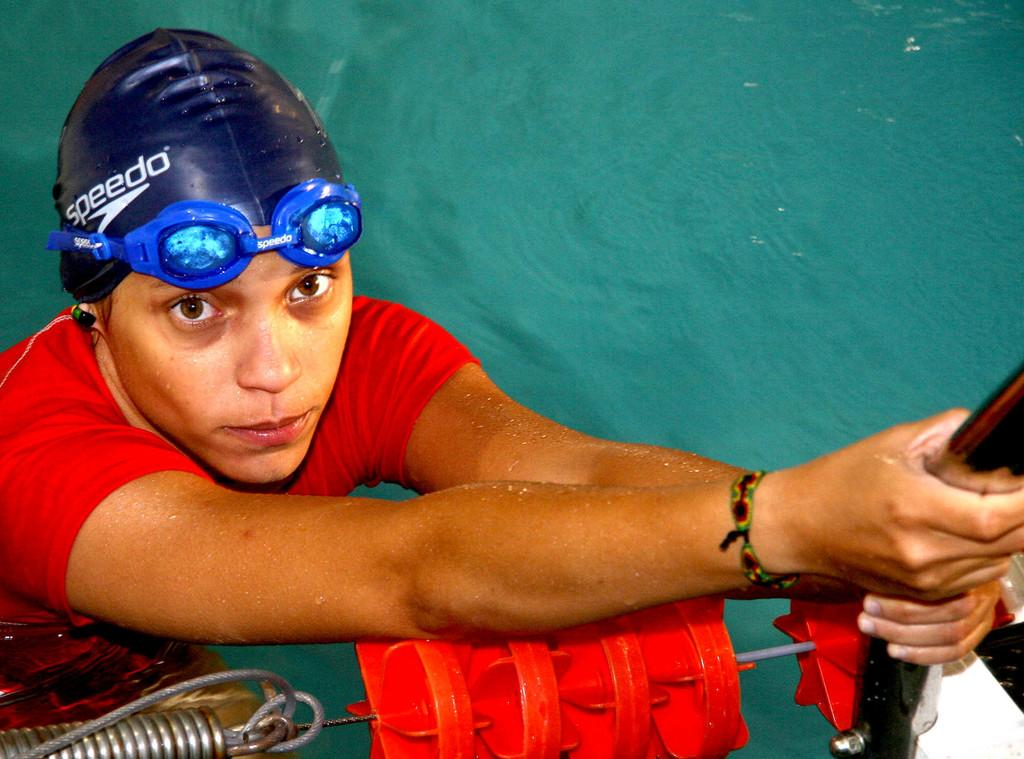Who is present in the image? There is a woman in the image. What is the woman holding in the image? The woman is holding a pole. Where is the woman located in the image? The woman is in the water. What else can be seen in the image besides the woman? There is a rope visible in the image, as well as other objects. What type of eggnog is the woman drinking in the image? There is no eggnog present in the image; the woman is holding a pole and is in the water. How many coats can be seen on the woman in the image? There is no coat visible on the woman in the image; she is in the water holding a pole. 